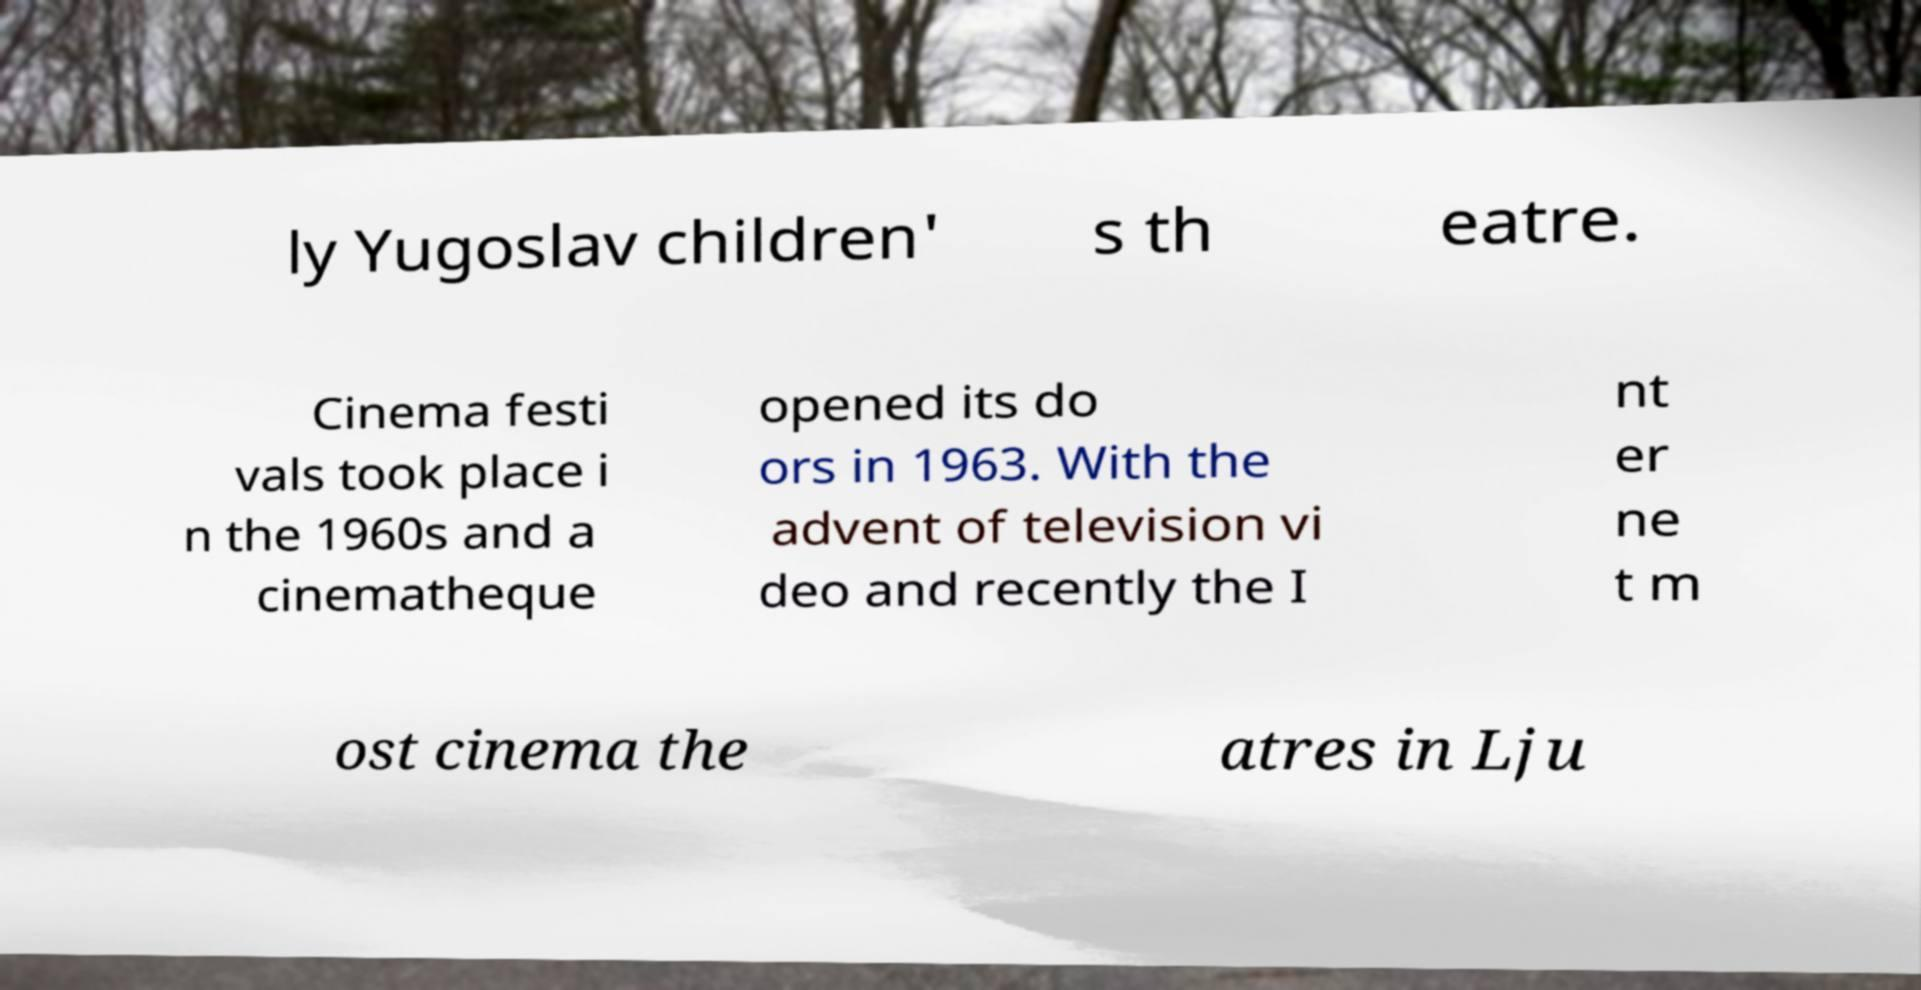Can you accurately transcribe the text from the provided image for me? ly Yugoslav children' s th eatre. Cinema festi vals took place i n the 1960s and a cinematheque opened its do ors in 1963. With the advent of television vi deo and recently the I nt er ne t m ost cinema the atres in Lju 